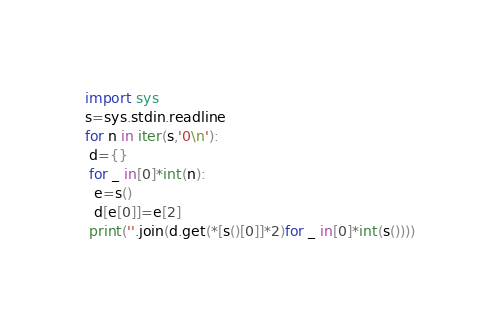<code> <loc_0><loc_0><loc_500><loc_500><_Python_>import sys
s=sys.stdin.readline
for n in iter(s,'0\n'):
 d={}
 for _ in[0]*int(n):
  e=s()
  d[e[0]]=e[2]
 print(''.join(d.get(*[s()[0]]*2)for _ in[0]*int(s())))
</code> 